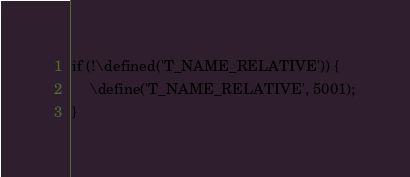<code> <loc_0><loc_0><loc_500><loc_500><_PHP_>if (!\defined('T_NAME_RELATIVE')) {
    \define('T_NAME_RELATIVE', 5001);
}
</code> 